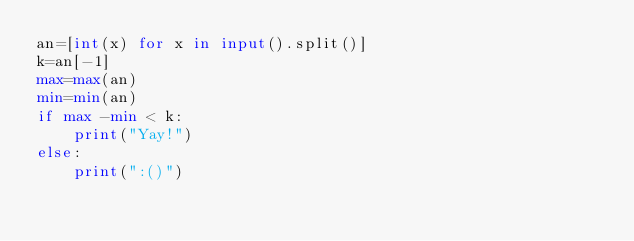Convert code to text. <code><loc_0><loc_0><loc_500><loc_500><_Python_>an=[int(x) for x in input().split()]
k=an[-1]
max=max(an)
min=min(an)
if max -min < k:
    print("Yay!")
else:
    print(":()")</code> 